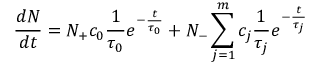Convert formula to latex. <formula><loc_0><loc_0><loc_500><loc_500>\frac { d N } { d t } = N _ { + } c _ { 0 } \frac { 1 } { \tau _ { 0 } } e ^ { - \frac { t } { \tau _ { 0 } } } + N _ { - } \sum _ { j = 1 } ^ { m } c _ { j } \frac { 1 } { \tau _ { j } } e ^ { - \frac { t } { \tau _ { j } } }</formula> 